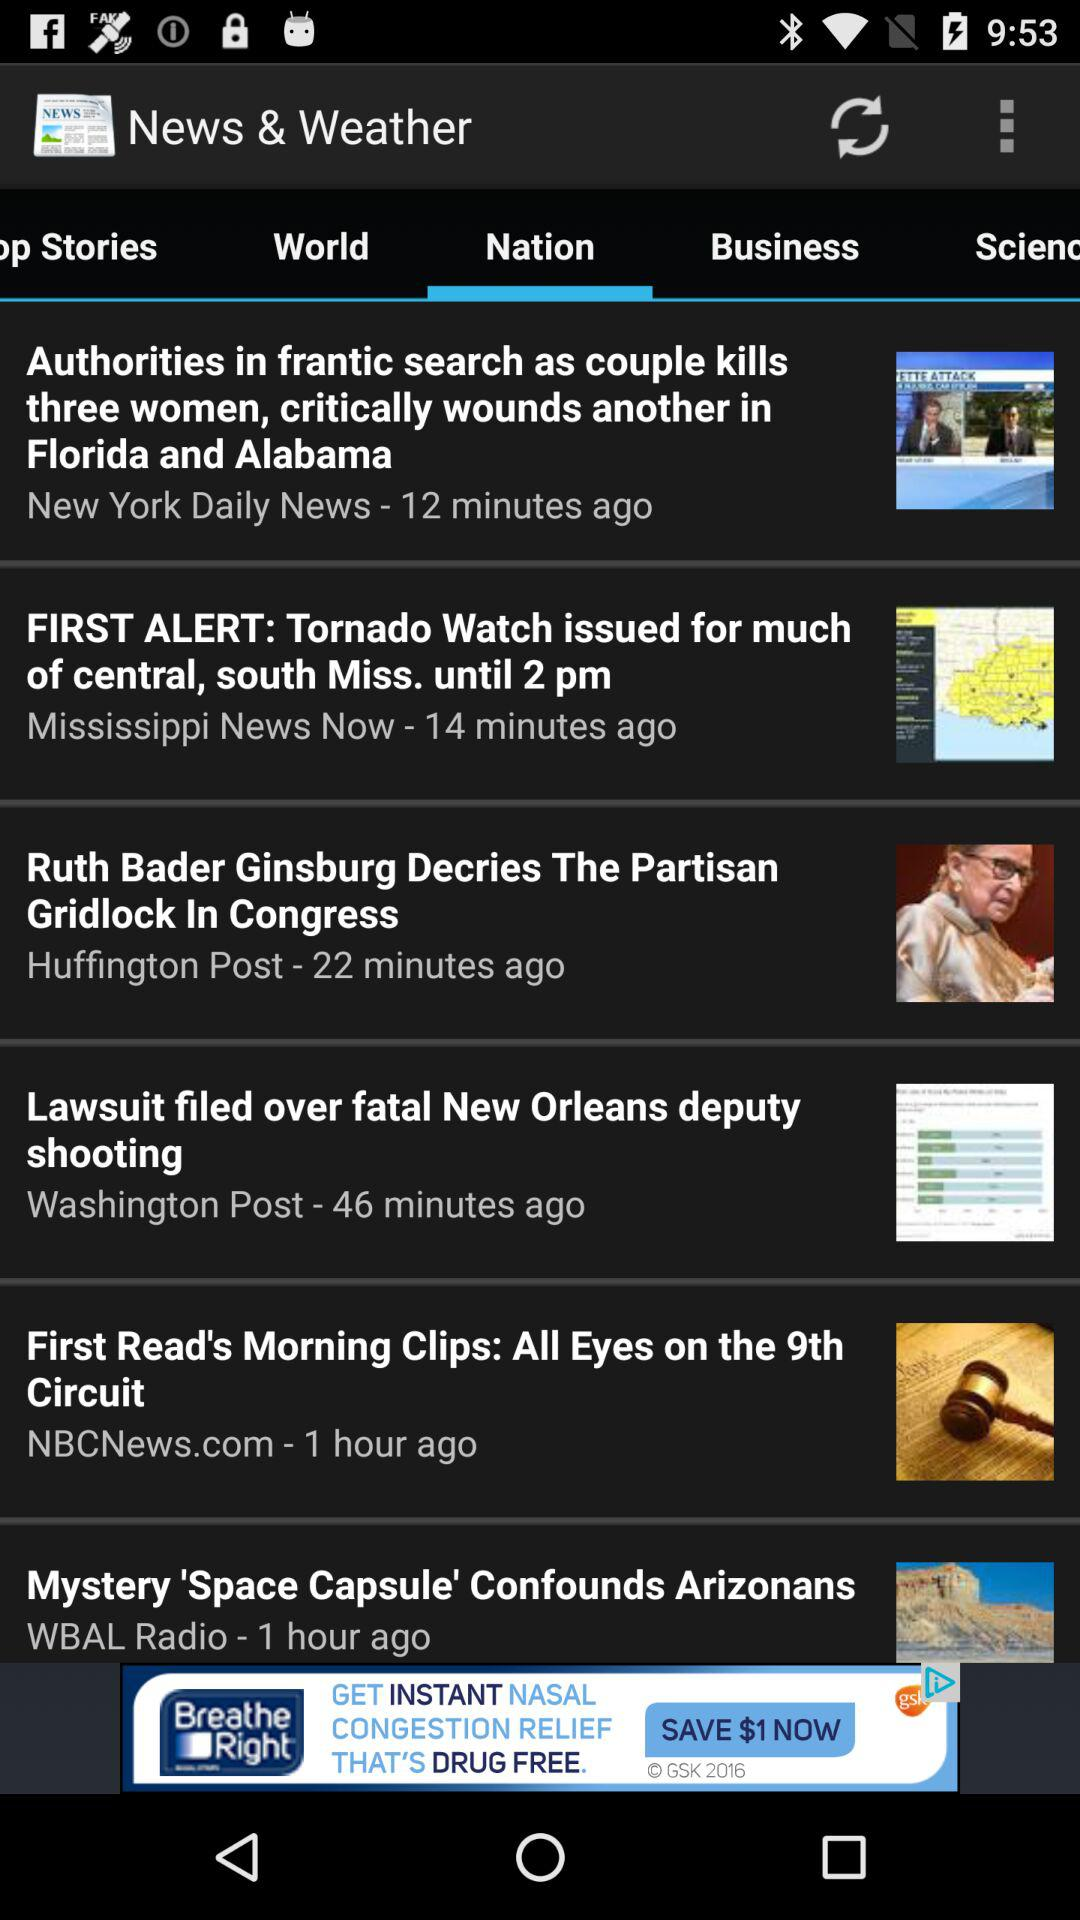How many stories are shown on the screen?
Answer the question using a single word or phrase. 6 